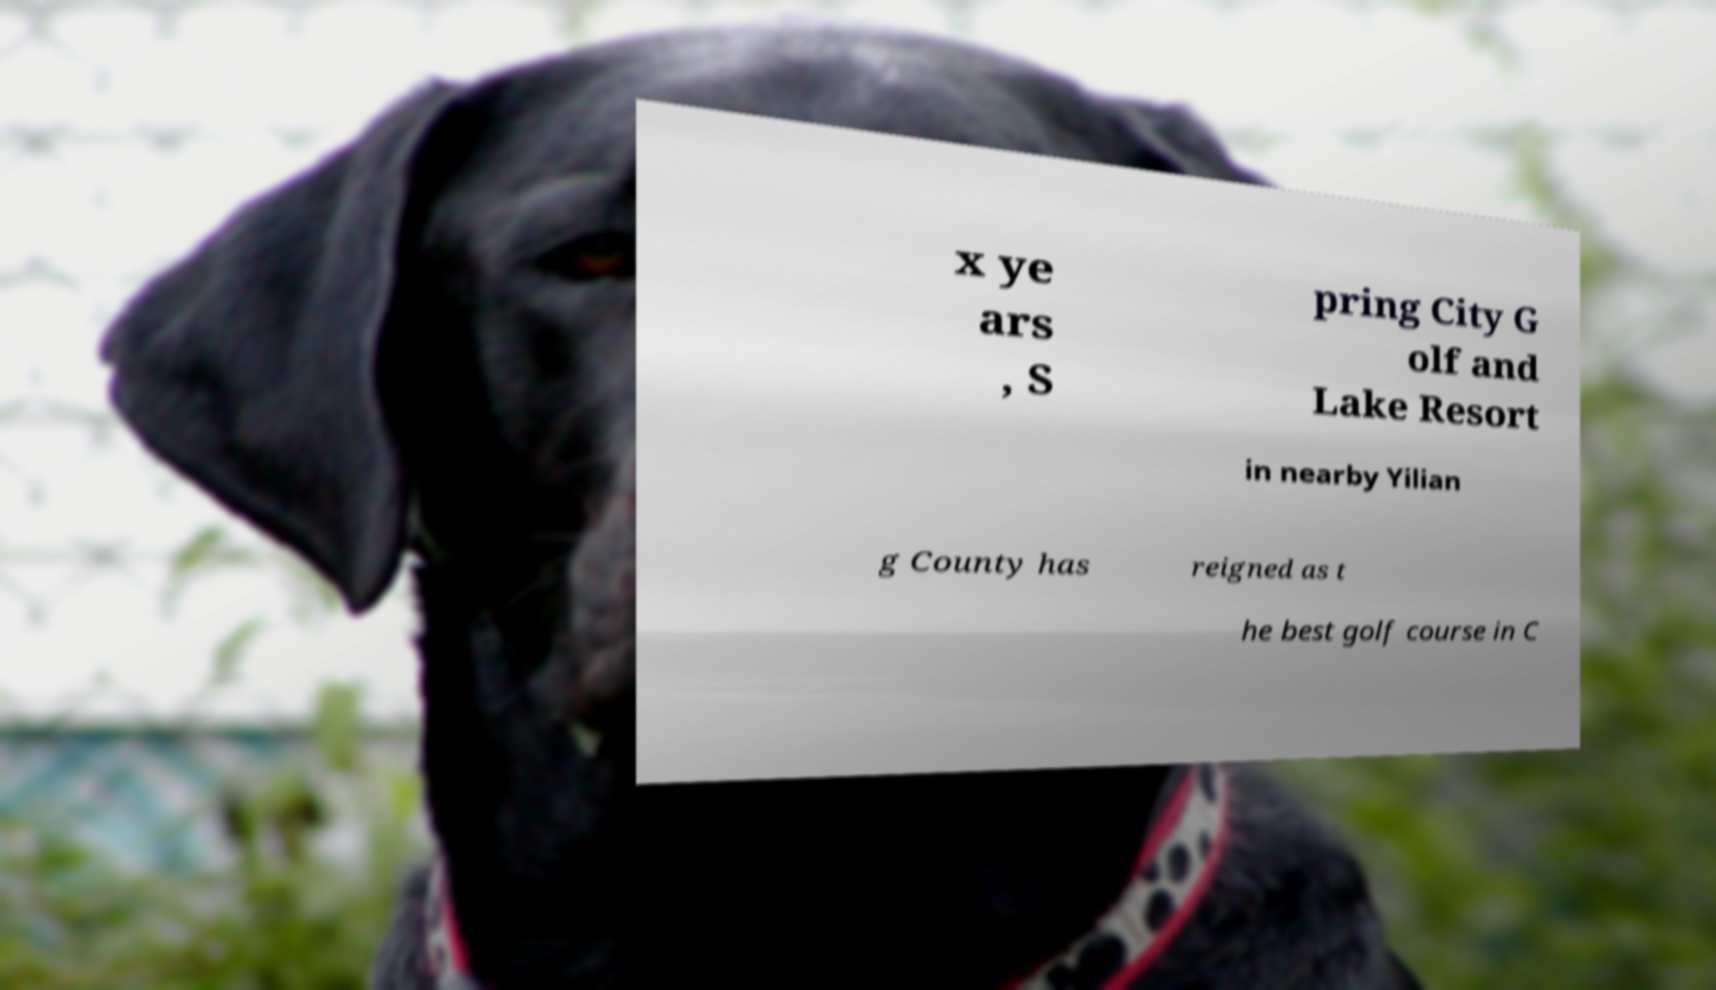Can you accurately transcribe the text from the provided image for me? x ye ars , S pring City G olf and Lake Resort in nearby Yilian g County has reigned as t he best golf course in C 